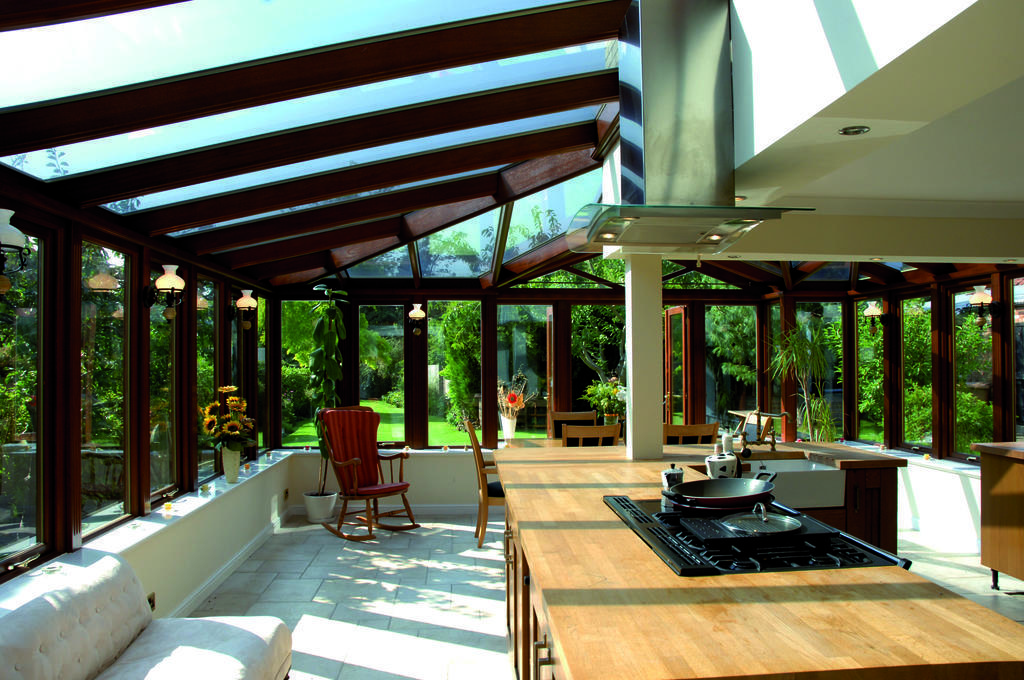In one or two sentences, can you explain what this image depicts? In this picture we can see chair, house plant with pot. This is a sofa. This is a floor. Here on the table we can see a stove and a pan on it. Through window glass we can see trees, plants and grass. These are lights. 